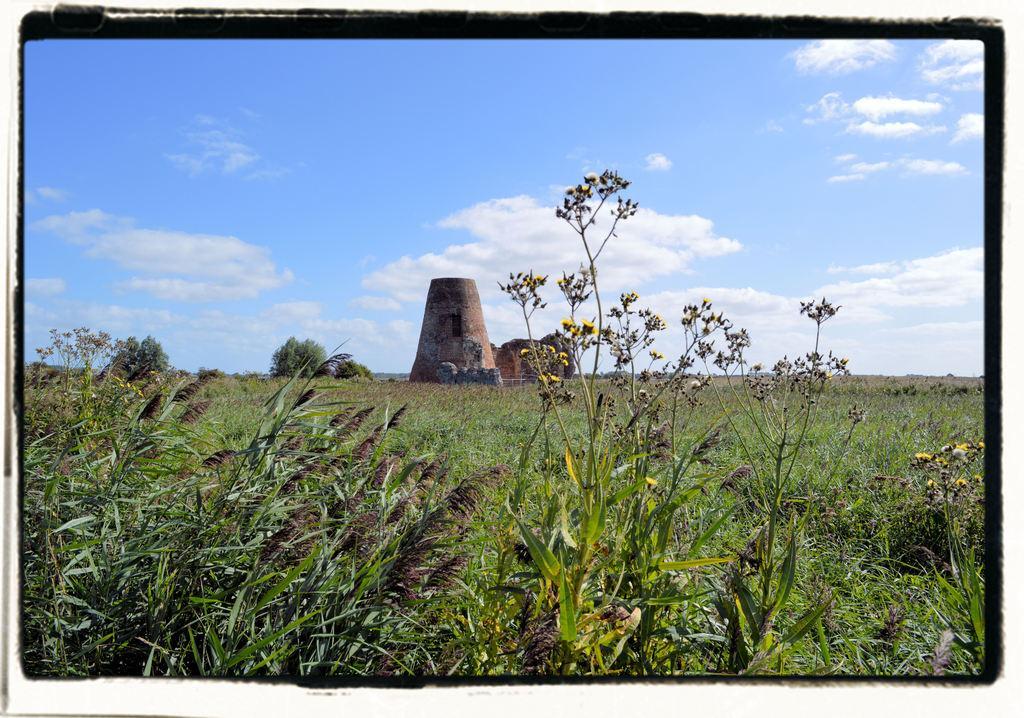How would you summarize this image in a sentence or two? In the center of the image we can see a tower. At the bottom there is grass. In the background there is sky. 